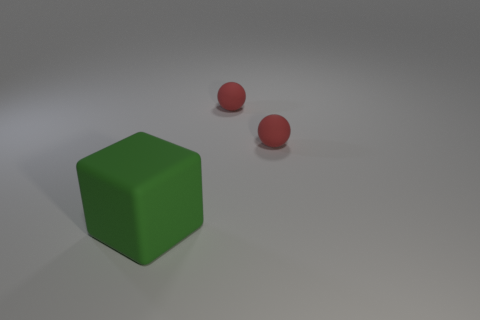What might be the purpose of placing these shapes in such a manner? The placement of the shapes might be an intentional choice designed to highlight contrast and similarities. For example, the distinct colors, red and green, are complementary and may suggest a visual exercise in comparing colors or studying shape interactions. Additionally, the difference in size between the cube and the spheres can prompt a study of proportions and spatial relationships in compositional design. 